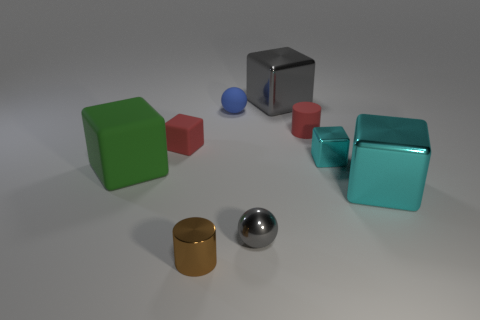Subtract 2 blocks. How many blocks are left? 3 Subtract all green cubes. How many cubes are left? 4 Subtract all small red blocks. How many blocks are left? 4 Subtract all purple cubes. Subtract all brown cylinders. How many cubes are left? 5 Add 1 small gray metallic objects. How many objects exist? 10 Subtract all spheres. How many objects are left? 7 Add 4 cylinders. How many cylinders exist? 6 Subtract 0 purple cylinders. How many objects are left? 9 Subtract all small brown cylinders. Subtract all large green matte things. How many objects are left? 7 Add 5 matte cubes. How many matte cubes are left? 7 